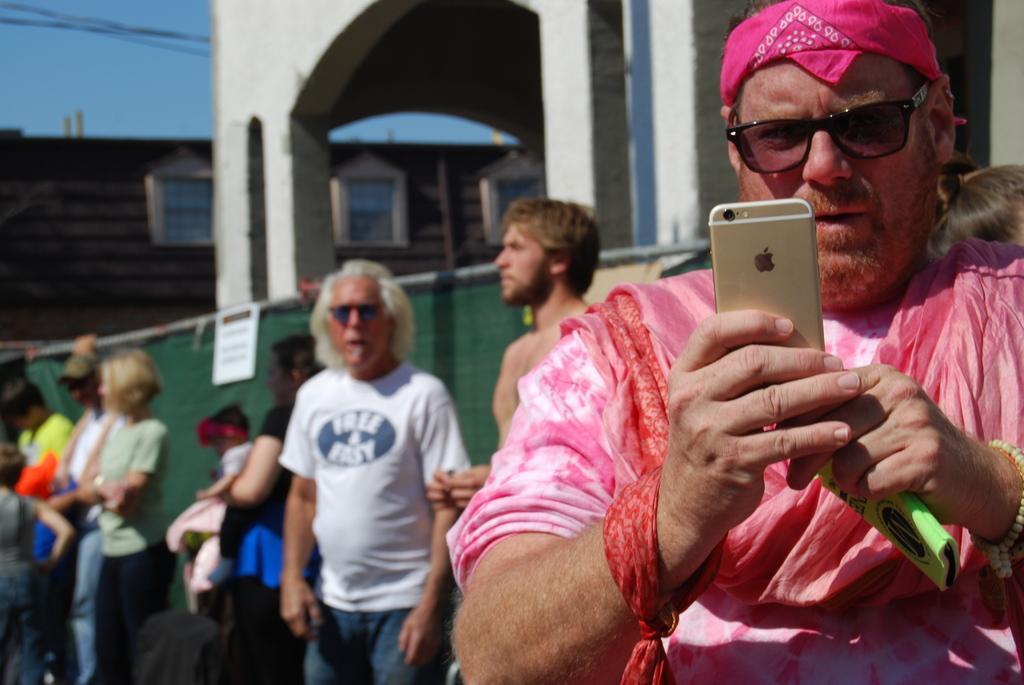In one or two sentences, can you explain what this image depicts? In this image we can see there is a man standing and holding phone behind him there are so many people standing together beside the building. 